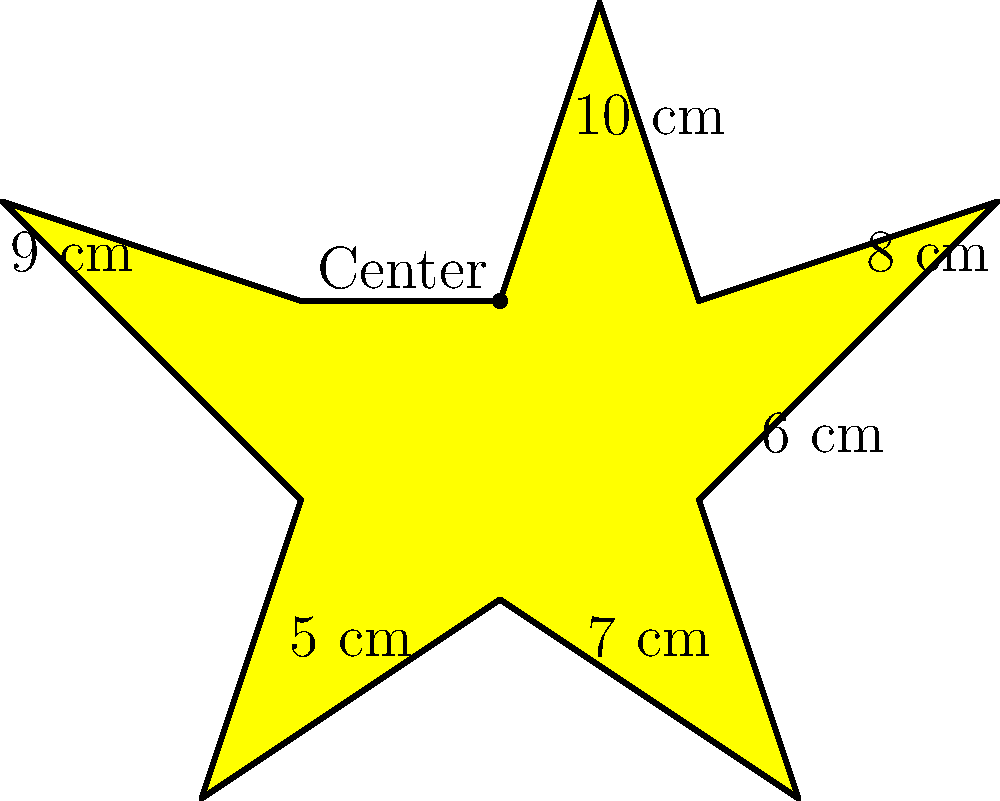As a talented screenwriter working closely with the director on script development, you've been tasked with designing a star-shaped award plaque for an upcoming film festival. The plaque's shape is a 10-pointed star, with alternating long and short points. The distances from the center to each point are given in the diagram. Calculate the perimeter of the star-shaped plaque. To find the perimeter of the star-shaped plaque, we need to calculate the length of each side and sum them up. Here's how we can approach this:

1. Identify the 10 sides of the star:
   - 5 long sides (connecting long points to short points)
   - 5 short sides (connecting short points to long points)

2. Calculate the length of a long side using the Pythagorean theorem:
   $\text{Long side} = \sqrt{(10-8)^2 + (8^2)} = \sqrt{4 + 64} = \sqrt{68} \approx 8.25$ cm

3. Calculate the length of a short side using the Pythagorean theorem:
   $\text{Short side} = \sqrt{(8-6)^2 + (6^2)} = \sqrt{4 + 36} = \sqrt{40} \approx 6.32$ cm

4. Calculate the total perimeter:
   $\text{Perimeter} = 5 \times \text{Long side} + 5 \times \text{Short side}$
   $= 5 \times \sqrt{68} + 5 \times \sqrt{40}$
   $= 5\sqrt{68} + 5\sqrt{40}$

5. Simplify:
   $\text{Perimeter} = 5(\sqrt{68} + \sqrt{40})$

6. Calculate the approximate value:
   $\text{Perimeter} \approx 5(8.25 + 6.32) = 5(14.57) = 72.85$ cm
Answer: $5(\sqrt{68} + \sqrt{40})$ cm or approximately 72.85 cm 